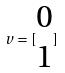<formula> <loc_0><loc_0><loc_500><loc_500>v = [ \begin{matrix} 0 \\ 1 \end{matrix} ]</formula> 